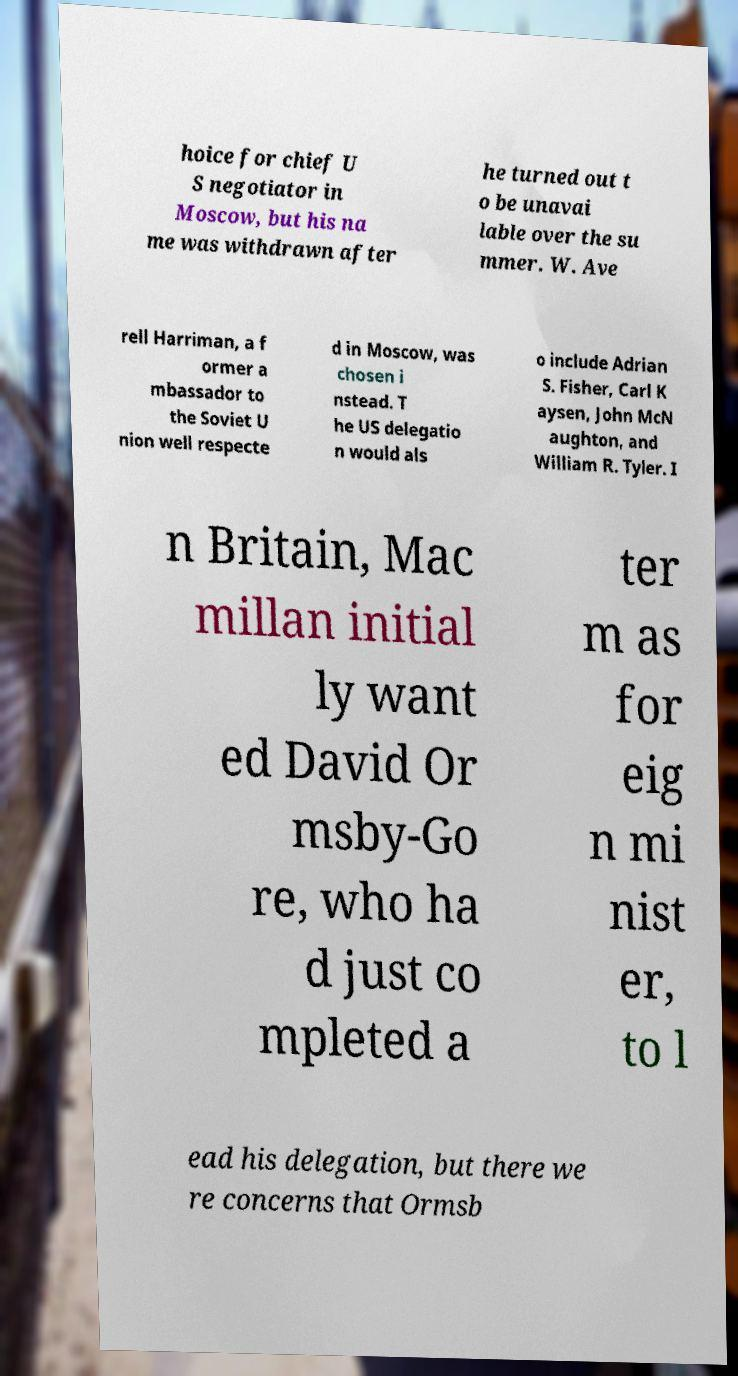What messages or text are displayed in this image? I need them in a readable, typed format. hoice for chief U S negotiator in Moscow, but his na me was withdrawn after he turned out t o be unavai lable over the su mmer. W. Ave rell Harriman, a f ormer a mbassador to the Soviet U nion well respecte d in Moscow, was chosen i nstead. T he US delegatio n would als o include Adrian S. Fisher, Carl K aysen, John McN aughton, and William R. Tyler. I n Britain, Mac millan initial ly want ed David Or msby-Go re, who ha d just co mpleted a ter m as for eig n mi nist er, to l ead his delegation, but there we re concerns that Ormsb 